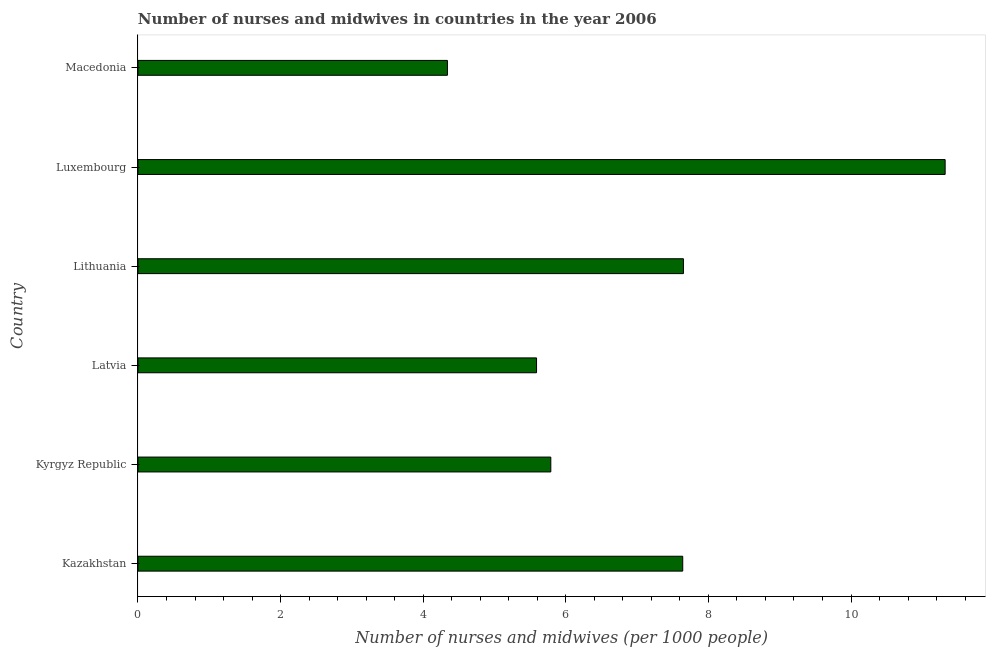Does the graph contain any zero values?
Keep it short and to the point. No. What is the title of the graph?
Offer a terse response. Number of nurses and midwives in countries in the year 2006. What is the label or title of the X-axis?
Offer a very short reply. Number of nurses and midwives (per 1000 people). What is the label or title of the Y-axis?
Offer a very short reply. Country. What is the number of nurses and midwives in Kyrgyz Republic?
Offer a terse response. 5.79. Across all countries, what is the maximum number of nurses and midwives?
Your response must be concise. 11.32. Across all countries, what is the minimum number of nurses and midwives?
Make the answer very short. 4.34. In which country was the number of nurses and midwives maximum?
Your answer should be compact. Luxembourg. In which country was the number of nurses and midwives minimum?
Make the answer very short. Macedonia. What is the sum of the number of nurses and midwives?
Offer a very short reply. 42.33. What is the difference between the number of nurses and midwives in Latvia and Luxembourg?
Keep it short and to the point. -5.73. What is the average number of nurses and midwives per country?
Make the answer very short. 7.05. What is the median number of nurses and midwives?
Offer a terse response. 6.71. In how many countries, is the number of nurses and midwives greater than 2.4 ?
Offer a terse response. 6. What is the ratio of the number of nurses and midwives in Lithuania to that in Luxembourg?
Keep it short and to the point. 0.68. Is the number of nurses and midwives in Kazakhstan less than that in Luxembourg?
Provide a succinct answer. Yes. Is the difference between the number of nurses and midwives in Lithuania and Macedonia greater than the difference between any two countries?
Your answer should be very brief. No. What is the difference between the highest and the second highest number of nurses and midwives?
Keep it short and to the point. 3.67. What is the difference between the highest and the lowest number of nurses and midwives?
Keep it short and to the point. 6.98. In how many countries, is the number of nurses and midwives greater than the average number of nurses and midwives taken over all countries?
Offer a terse response. 3. Are all the bars in the graph horizontal?
Your response must be concise. Yes. What is the difference between two consecutive major ticks on the X-axis?
Provide a short and direct response. 2. Are the values on the major ticks of X-axis written in scientific E-notation?
Provide a succinct answer. No. What is the Number of nurses and midwives (per 1000 people) of Kazakhstan?
Provide a short and direct response. 7.64. What is the Number of nurses and midwives (per 1000 people) of Kyrgyz Republic?
Keep it short and to the point. 5.79. What is the Number of nurses and midwives (per 1000 people) in Latvia?
Your answer should be very brief. 5.59. What is the Number of nurses and midwives (per 1000 people) of Lithuania?
Your answer should be very brief. 7.65. What is the Number of nurses and midwives (per 1000 people) of Luxembourg?
Your answer should be very brief. 11.32. What is the Number of nurses and midwives (per 1000 people) of Macedonia?
Make the answer very short. 4.34. What is the difference between the Number of nurses and midwives (per 1000 people) in Kazakhstan and Kyrgyz Republic?
Give a very brief answer. 1.85. What is the difference between the Number of nurses and midwives (per 1000 people) in Kazakhstan and Latvia?
Your response must be concise. 2.05. What is the difference between the Number of nurses and midwives (per 1000 people) in Kazakhstan and Lithuania?
Give a very brief answer. -0.01. What is the difference between the Number of nurses and midwives (per 1000 people) in Kazakhstan and Luxembourg?
Ensure brevity in your answer.  -3.68. What is the difference between the Number of nurses and midwives (per 1000 people) in Kyrgyz Republic and Latvia?
Offer a terse response. 0.2. What is the difference between the Number of nurses and midwives (per 1000 people) in Kyrgyz Republic and Lithuania?
Offer a very short reply. -1.86. What is the difference between the Number of nurses and midwives (per 1000 people) in Kyrgyz Republic and Luxembourg?
Offer a terse response. -5.53. What is the difference between the Number of nurses and midwives (per 1000 people) in Kyrgyz Republic and Macedonia?
Provide a succinct answer. 1.45. What is the difference between the Number of nurses and midwives (per 1000 people) in Latvia and Lithuania?
Offer a very short reply. -2.06. What is the difference between the Number of nurses and midwives (per 1000 people) in Latvia and Luxembourg?
Your answer should be compact. -5.73. What is the difference between the Number of nurses and midwives (per 1000 people) in Latvia and Macedonia?
Provide a short and direct response. 1.25. What is the difference between the Number of nurses and midwives (per 1000 people) in Lithuania and Luxembourg?
Make the answer very short. -3.67. What is the difference between the Number of nurses and midwives (per 1000 people) in Lithuania and Macedonia?
Keep it short and to the point. 3.31. What is the difference between the Number of nurses and midwives (per 1000 people) in Luxembourg and Macedonia?
Provide a succinct answer. 6.98. What is the ratio of the Number of nurses and midwives (per 1000 people) in Kazakhstan to that in Kyrgyz Republic?
Offer a terse response. 1.32. What is the ratio of the Number of nurses and midwives (per 1000 people) in Kazakhstan to that in Latvia?
Keep it short and to the point. 1.37. What is the ratio of the Number of nurses and midwives (per 1000 people) in Kazakhstan to that in Luxembourg?
Give a very brief answer. 0.68. What is the ratio of the Number of nurses and midwives (per 1000 people) in Kazakhstan to that in Macedonia?
Your answer should be compact. 1.76. What is the ratio of the Number of nurses and midwives (per 1000 people) in Kyrgyz Republic to that in Latvia?
Provide a short and direct response. 1.04. What is the ratio of the Number of nurses and midwives (per 1000 people) in Kyrgyz Republic to that in Lithuania?
Keep it short and to the point. 0.76. What is the ratio of the Number of nurses and midwives (per 1000 people) in Kyrgyz Republic to that in Luxembourg?
Keep it short and to the point. 0.51. What is the ratio of the Number of nurses and midwives (per 1000 people) in Kyrgyz Republic to that in Macedonia?
Provide a short and direct response. 1.33. What is the ratio of the Number of nurses and midwives (per 1000 people) in Latvia to that in Lithuania?
Give a very brief answer. 0.73. What is the ratio of the Number of nurses and midwives (per 1000 people) in Latvia to that in Luxembourg?
Give a very brief answer. 0.49. What is the ratio of the Number of nurses and midwives (per 1000 people) in Latvia to that in Macedonia?
Your answer should be compact. 1.29. What is the ratio of the Number of nurses and midwives (per 1000 people) in Lithuania to that in Luxembourg?
Give a very brief answer. 0.68. What is the ratio of the Number of nurses and midwives (per 1000 people) in Lithuania to that in Macedonia?
Provide a succinct answer. 1.76. What is the ratio of the Number of nurses and midwives (per 1000 people) in Luxembourg to that in Macedonia?
Give a very brief answer. 2.61. 